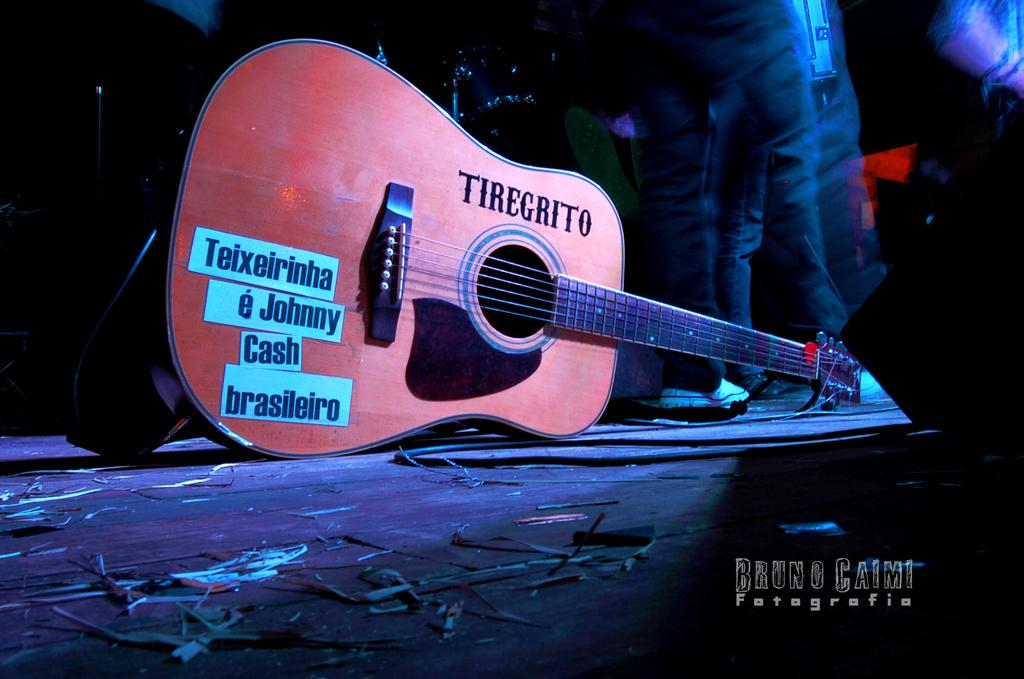What musical instrument is present in the image? There is a guitar in the image. Can you describe the guitar in the image? The image shows a guitar, but it does not provide any specific details about its color, shape, or condition. What might someone do with the guitar in the image? Someone might play the guitar, tune it, or hold it in the image. How many eyes can be seen on the guitar in the image? There are no eyes visible on the guitar in the image, as guitars do not have eyes. 